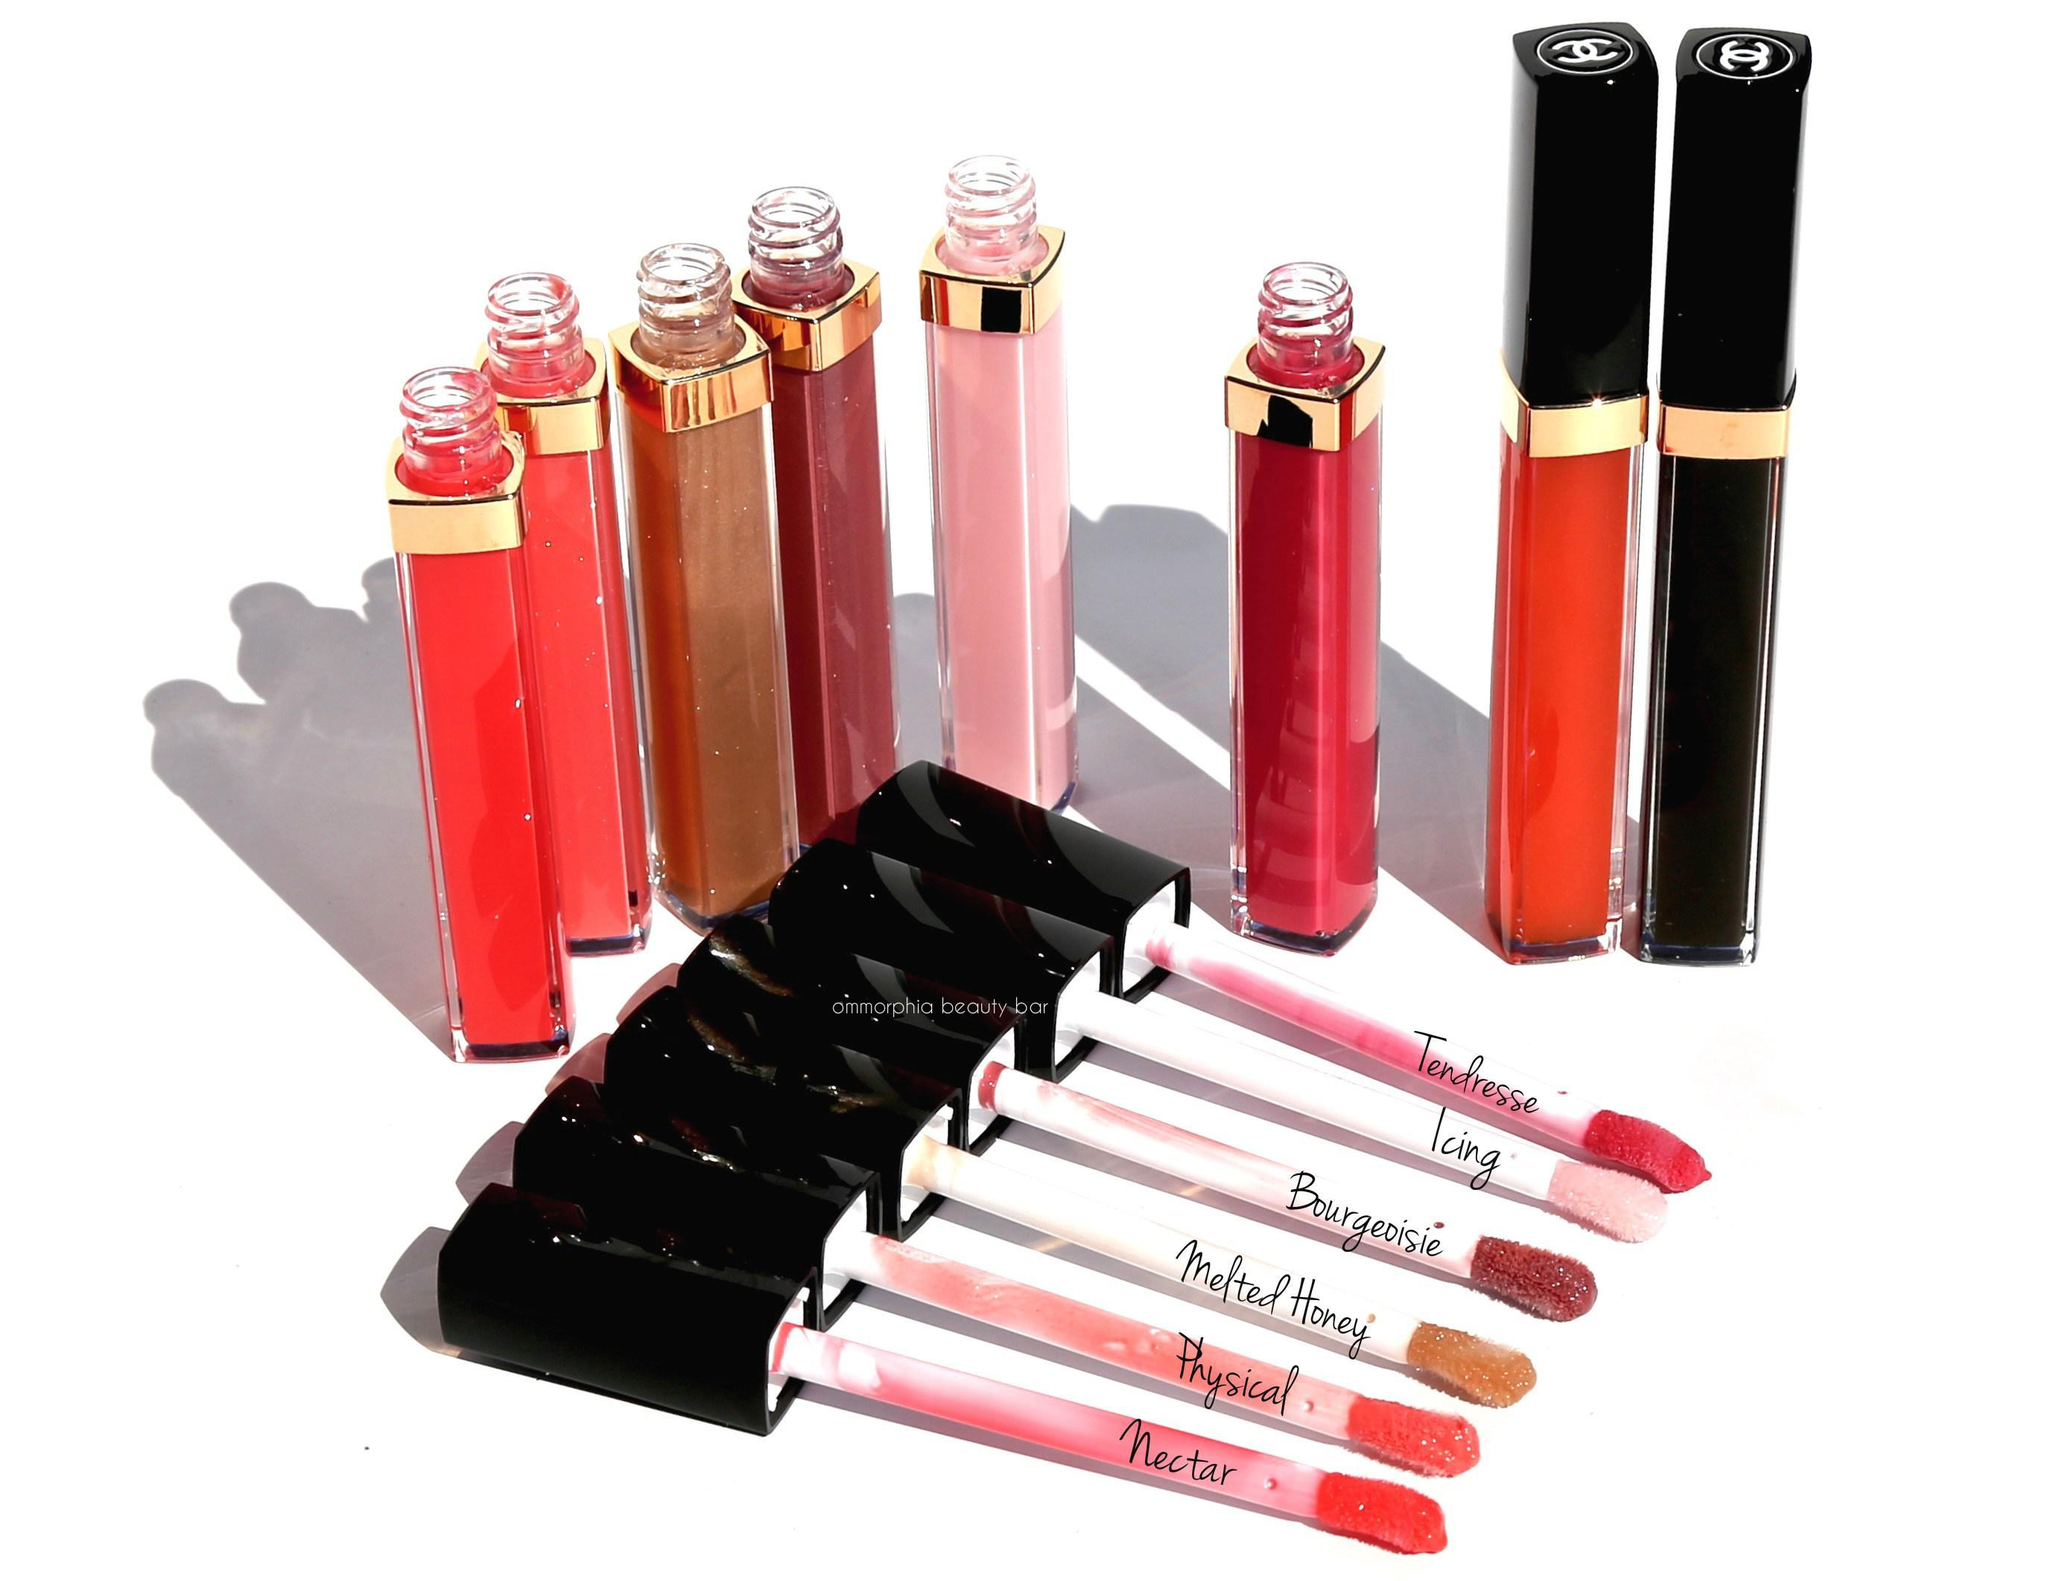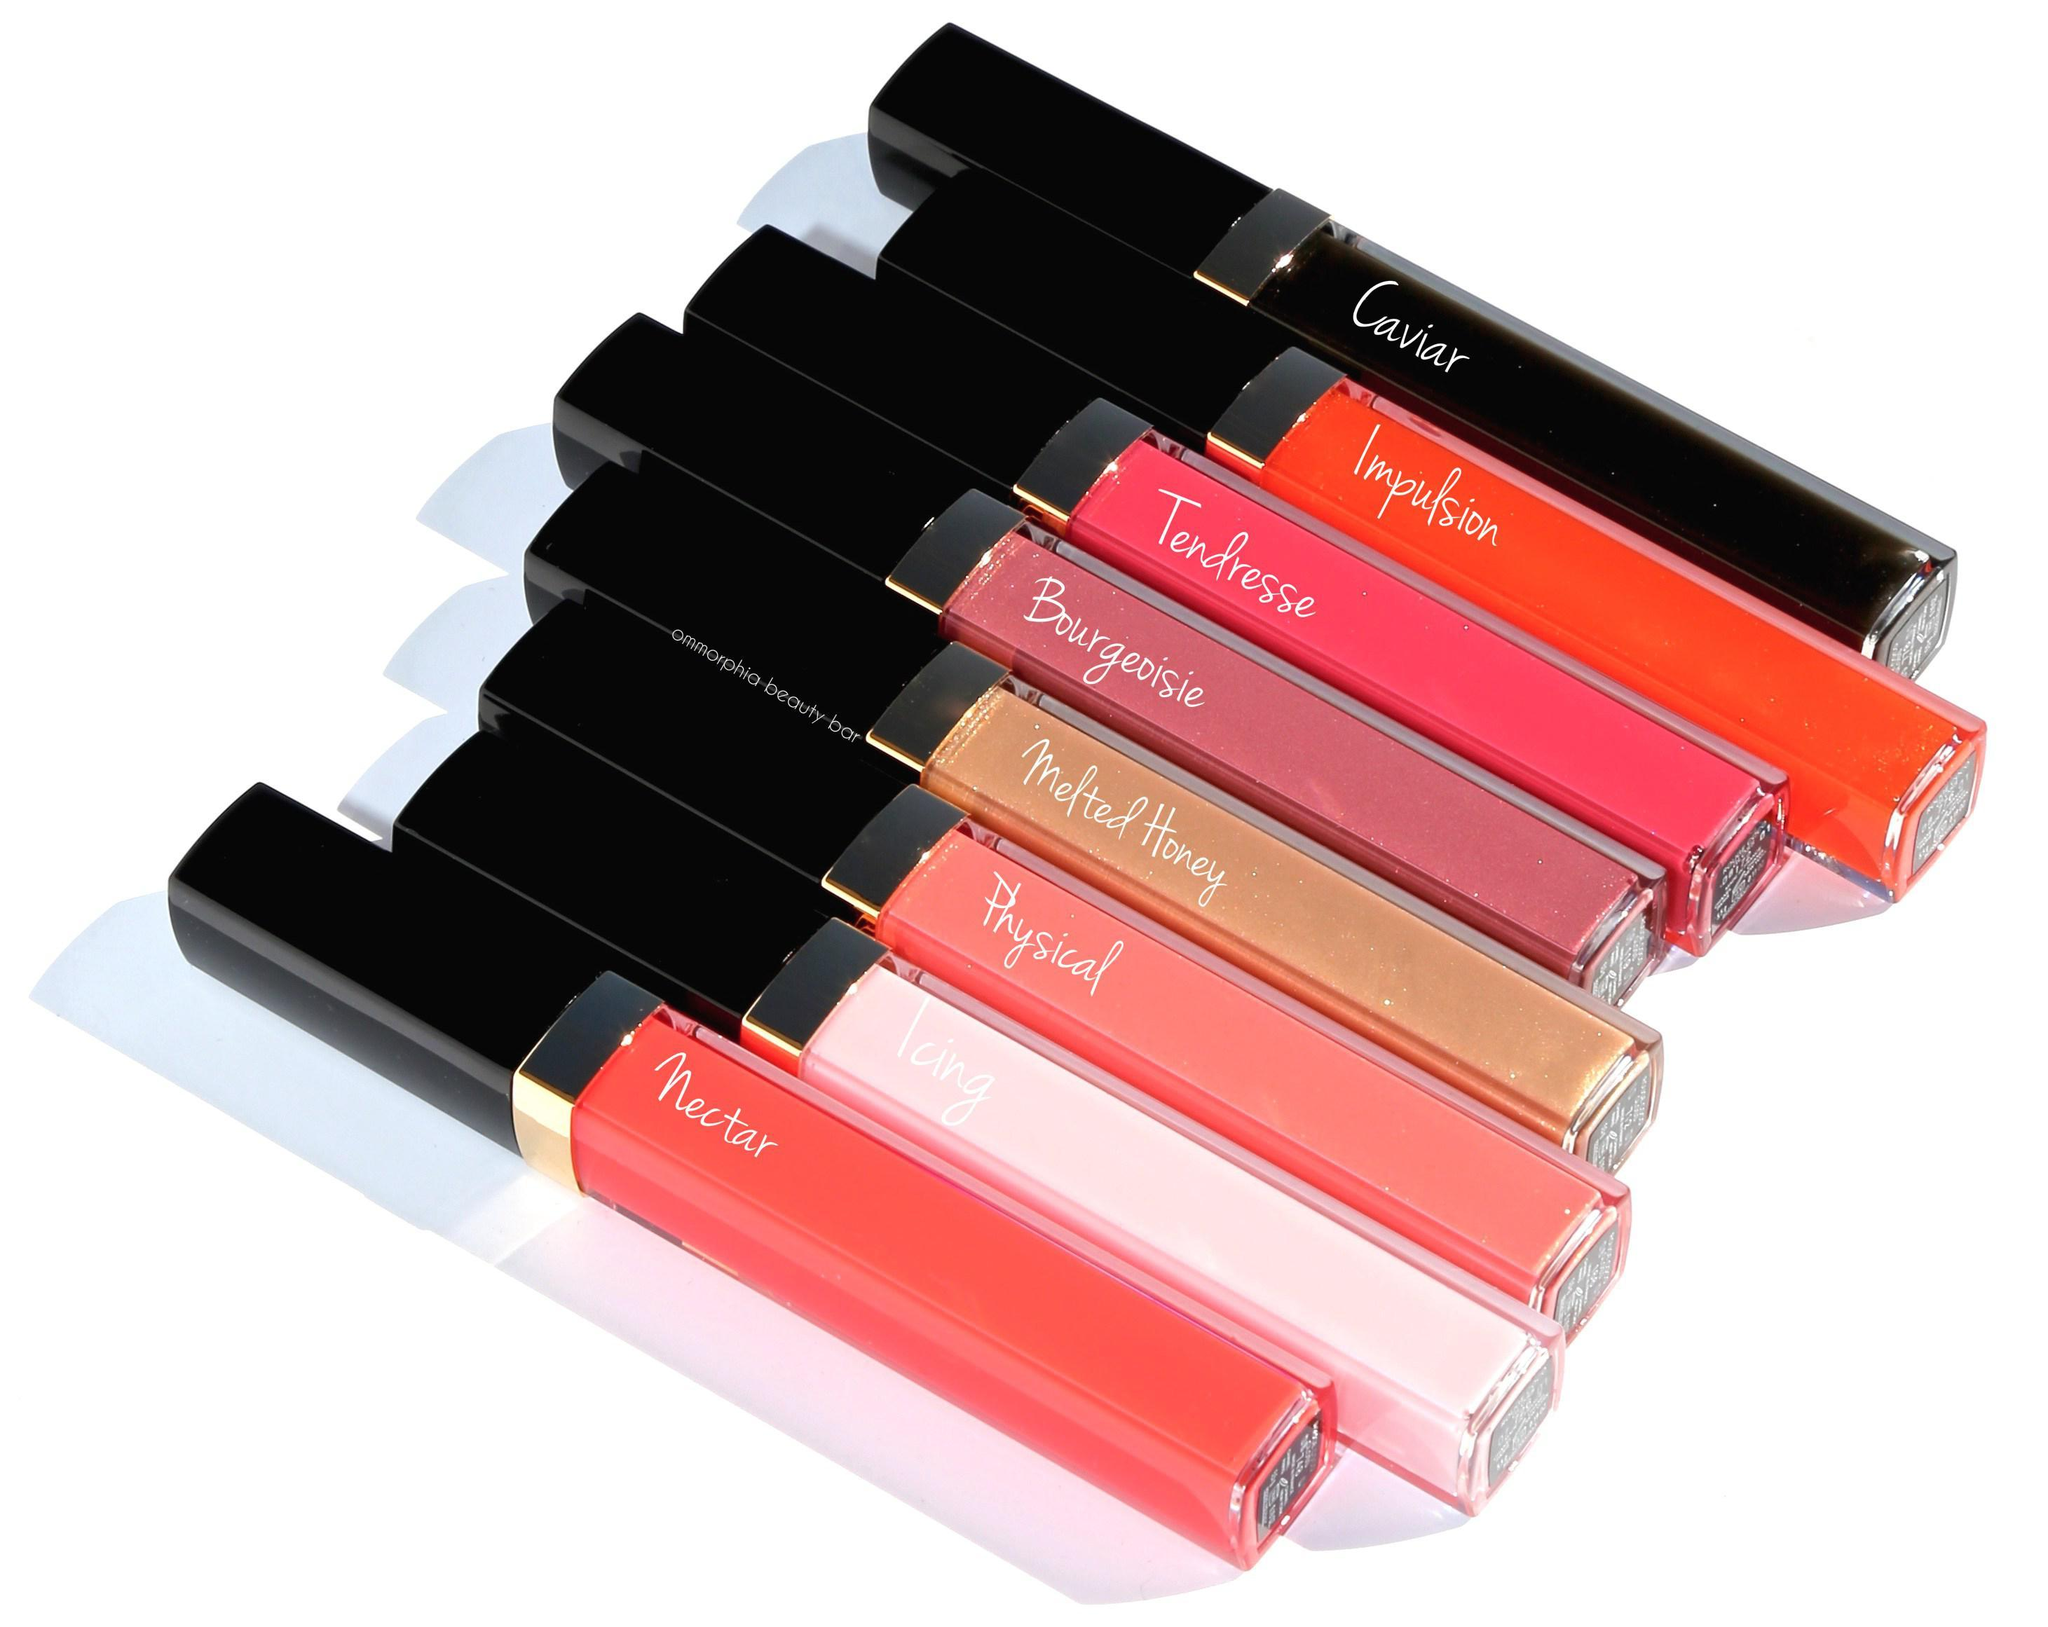The first image is the image on the left, the second image is the image on the right. For the images shown, is this caption "The left image includes at least one capped and one uncapped lipstick wand, and the right image includes at least one capped lipstick wand but no uncapped lip makeup." true? Answer yes or no. Yes. The first image is the image on the left, the second image is the image on the right. For the images shown, is this caption "There are at least 8 different shades of lip gloss in their tubes." true? Answer yes or no. Yes. 